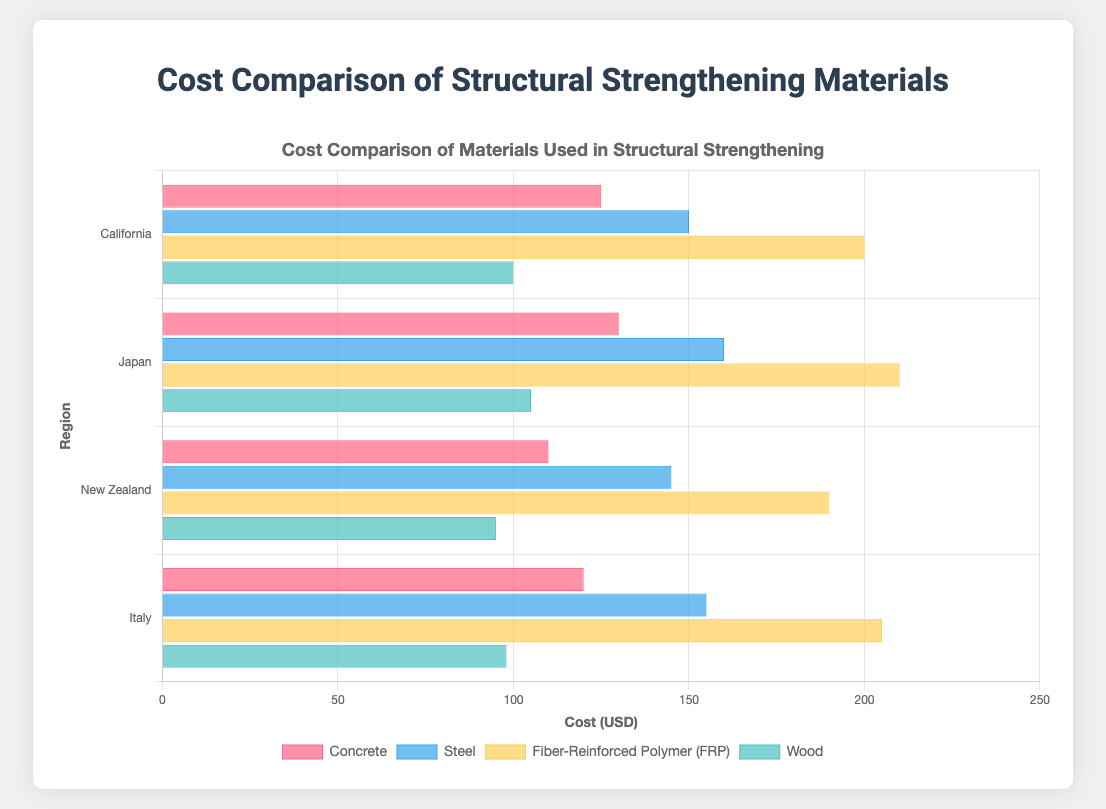Which material is the most expensive in California? Refer to the costs for each material in California. Concrete is $125, Steel is $150, Fiber-Reinforced Polymer (FRP) is $200, and Wood is $100. FRP has the highest cost.
Answer: Fiber-Reinforced Polymer (FRP) Compare the cost of Concrete in Japan and New Zealand. Which is higher and by how much? The cost of Concrete in Japan is $130, and in New Zealand, it is $110. The difference is $130 - $110 = $20. The cost in Japan is higher by $20.
Answer: Japan by $20 What’s the average cost of Steel across all regions? The costs of Steel are $150 (California), $160 (Japan), $145 (New Zealand), and $155 (Italy). The average is calculated as ($150 + $160 + $145 + $155) / 4 = $152.5.
Answer: $152.5 Which region has the lowest cost for Wood, and what is that cost? The costs for Wood are $100 (California), $105 (Japan), $95 (New Zealand), and $98 (Italy). New Zealand has the lowest cost at $95.
Answer: New Zealand at $95 How much more expensive is Fiber-Reinforced Polymer (FRP) in Japan than in New Zealand? The cost of FRP in Japan is $210 and in New Zealand, it is $190. The difference is $210 - $190 = $20.
Answer: $20 Which material has the most uniform cost across all regions and what are the costs? Calculate the range for each material:
Concrete: ($130 - $110 = $20)
Steel: ($160 - $145 = $15)
FRP: ($210 - $190 = $20)
Wood: ($105 - $95 = $10).
Wood has the smallest range of $10, hence it's the most uniform.
Answer: Wood, $100 (California), $105 (Japan), $95 (New Zealand), $98 (Italy) What’s the total cost of all materials in Italy? Sum the costs for each material in Italy: Concrete $120, Steel $155, FRP $205, and Wood $98. The total is $120 + $155 + $205 + $98 = $578.
Answer: $578 If a project in California uses equal amounts of Concrete and Steel, what is the combined cost? The costs in California are $125 for Concrete and $150 for Steel. The combined cost is $125 + $150 = $275.
Answer: $275 Identify the material that is consistently the most expensive across all regions. For each region, identify the highest cost material:
California: FRP ($200)
Japan: FRP ($210)
New Zealand: FRP ($190)
Italy: FRP ($205).
FRP is consistently the most expensive in all regions.
Answer: Fiber-Reinforced Polymer (FRP) Visualize the most common color used to represent Steel in the chart and describe it. Based on the chart’s description: Steel is represented with a blue color. Thus, the most common color representing Steel is blue.
Answer: Blue 